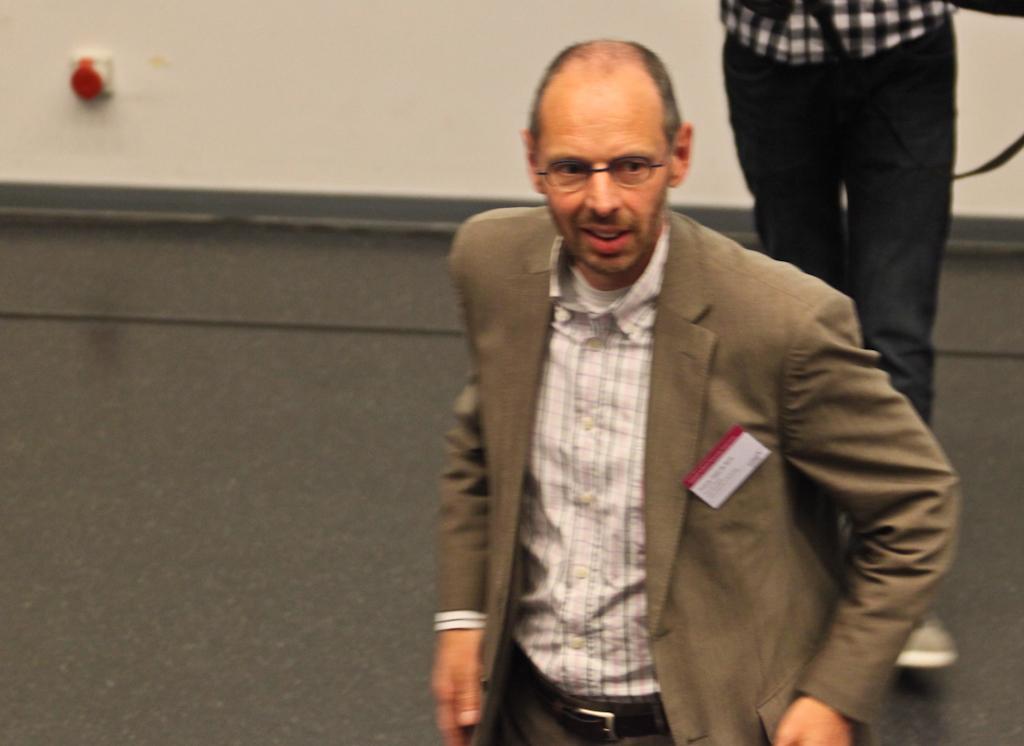Please provide a concise description of this image. In this image there is a person wearing a blazer. Right side there is a person walking on the floor. Background there is a wall. 